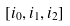<formula> <loc_0><loc_0><loc_500><loc_500>[ i _ { 0 } , i _ { 1 } , i _ { 2 } ]</formula> 